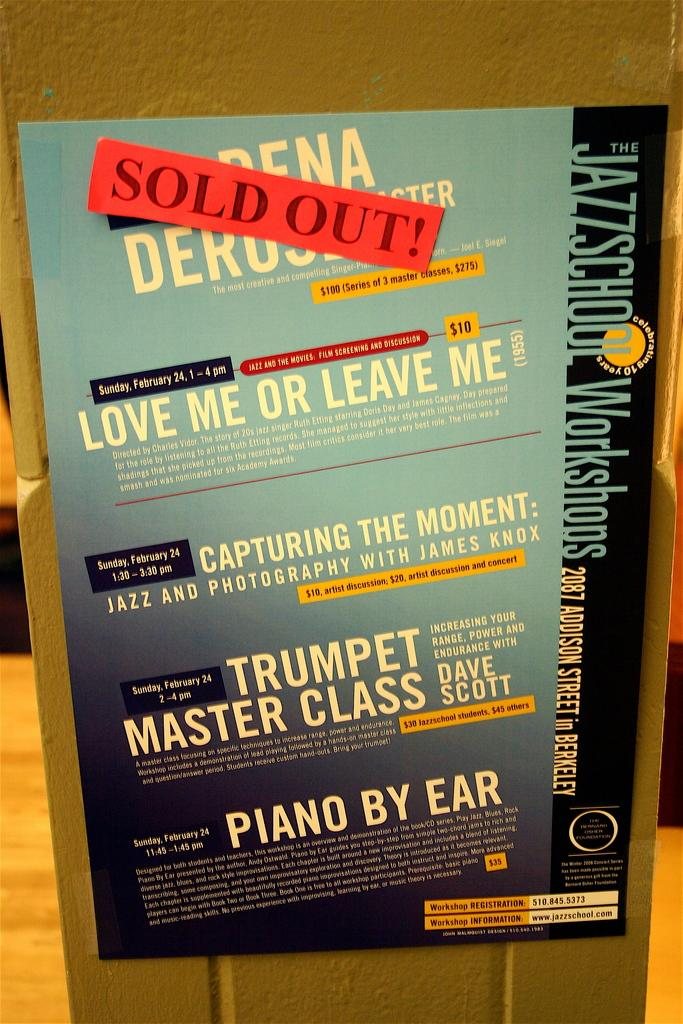<image>
Write a terse but informative summary of the picture. A poster with a red SOLD OUT! sticker on it 